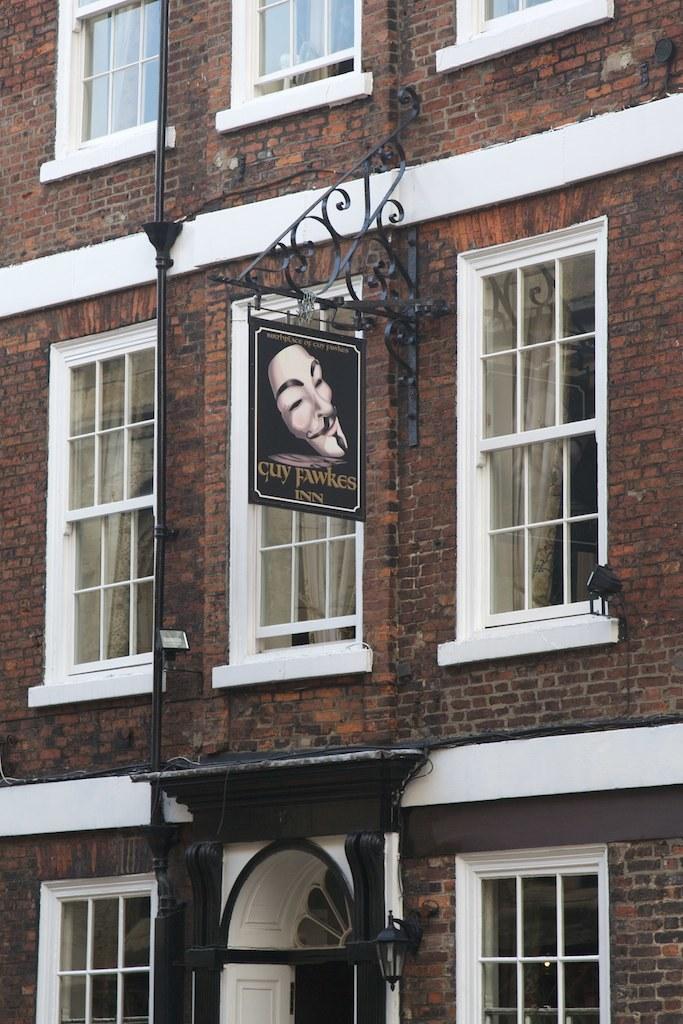In one or two sentences, can you explain what this image depicts? In this image there is a building, and in the center there is a board and there is a pipe, windows and light. 